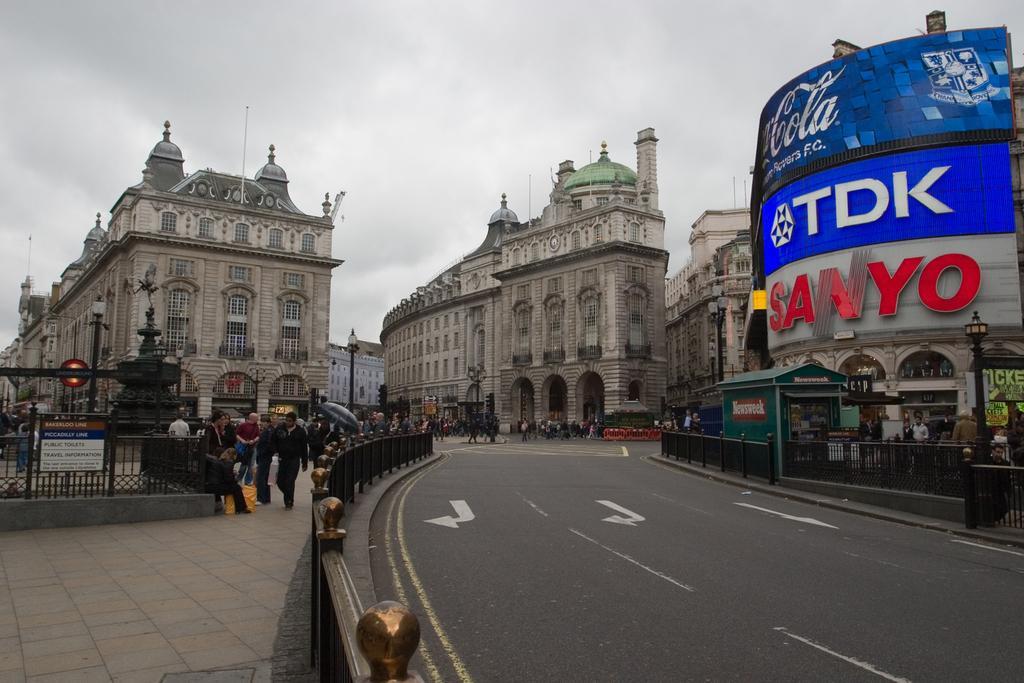Could you give a brief overview of what you see in this image? In the picture there is a road, there is a footpath, there are many people present, there are poles with the lights, there are buildings, there is a some text present on one of the buildings, there is a cloudy sky 